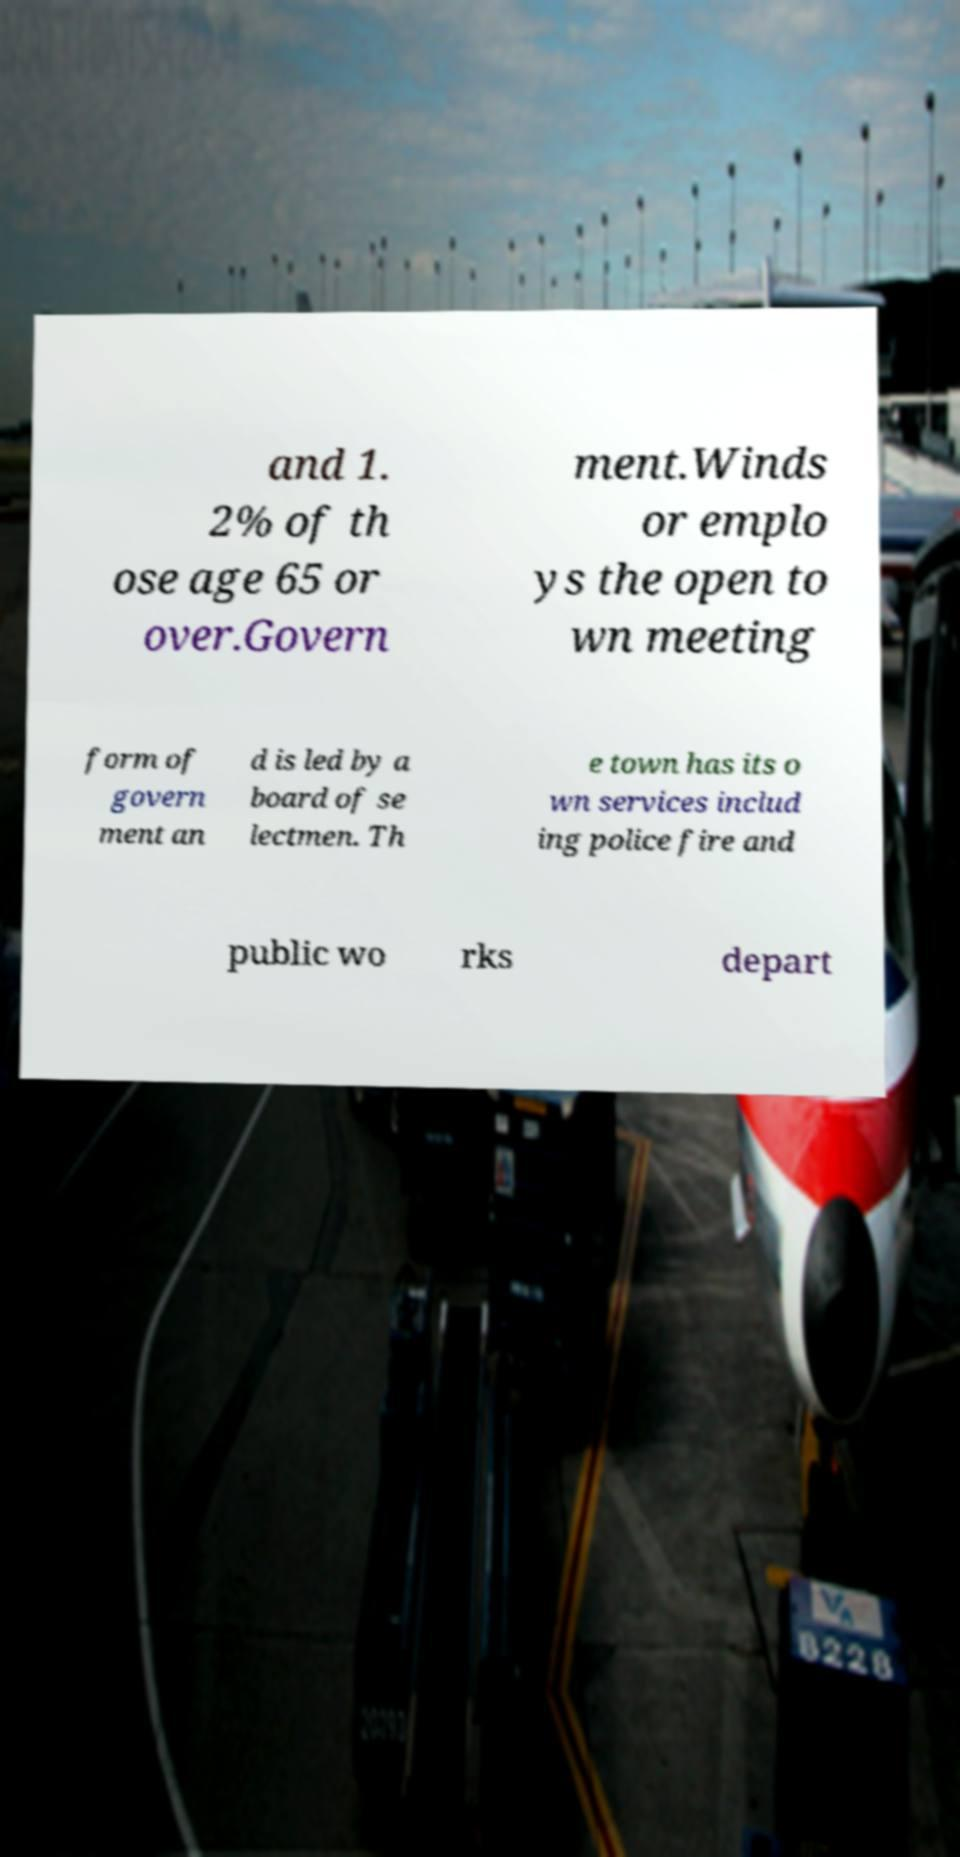I need the written content from this picture converted into text. Can you do that? and 1. 2% of th ose age 65 or over.Govern ment.Winds or emplo ys the open to wn meeting form of govern ment an d is led by a board of se lectmen. Th e town has its o wn services includ ing police fire and public wo rks depart 